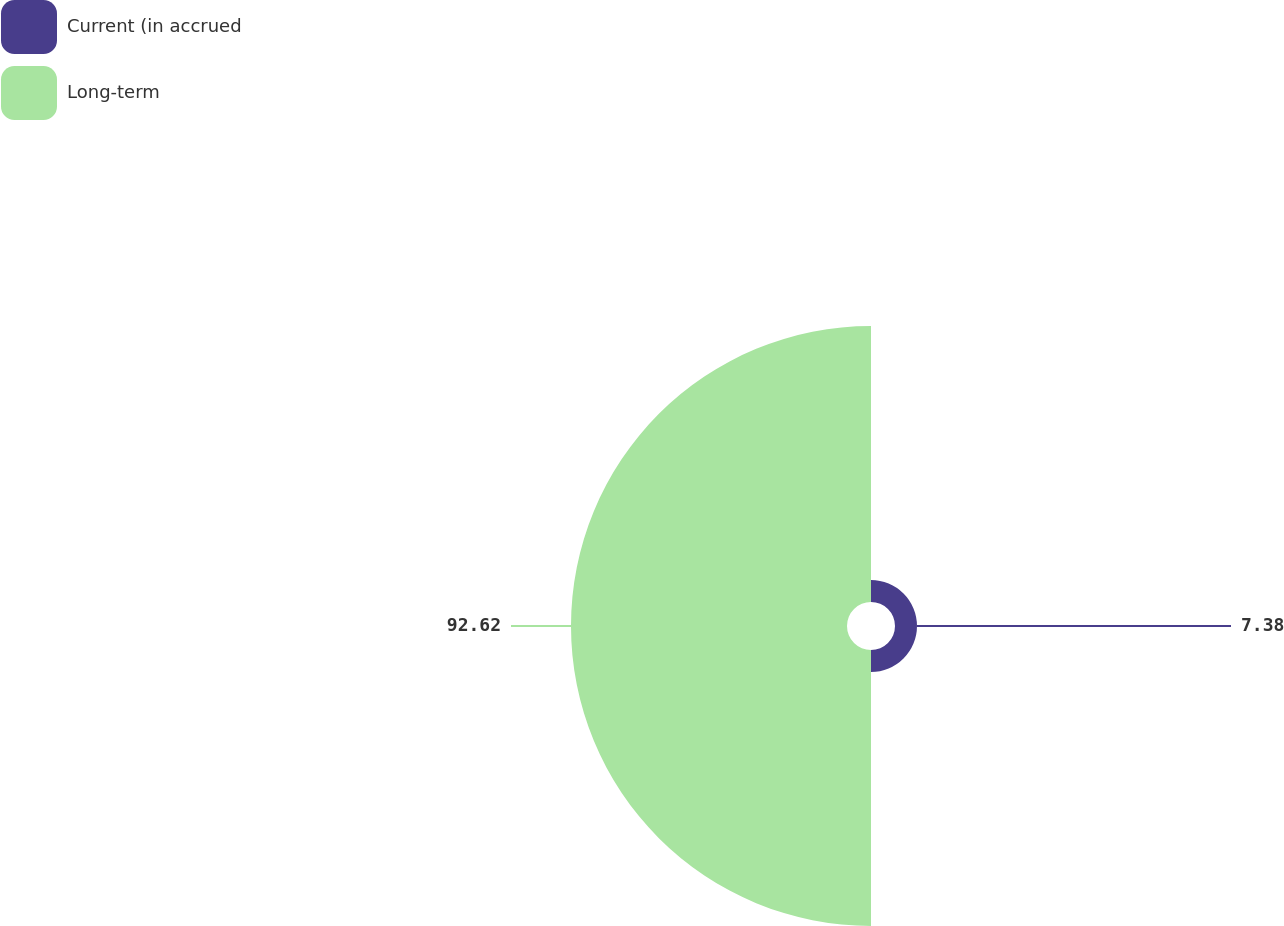<chart> <loc_0><loc_0><loc_500><loc_500><pie_chart><fcel>Current (in accrued<fcel>Long-term<nl><fcel>7.38%<fcel>92.62%<nl></chart> 